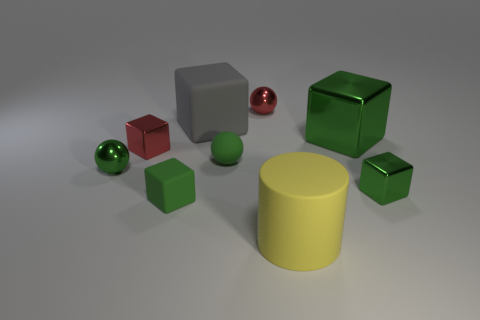Is there anything else that is the same shape as the large yellow rubber thing?
Your answer should be compact. No. What color is the big cube that is made of the same material as the yellow object?
Provide a succinct answer. Gray. There is a shiny sphere that is behind the small shiny cube that is to the left of the yellow cylinder; are there any rubber balls behind it?
Give a very brief answer. No. Is the number of big gray blocks that are on the right side of the tiny rubber cube less than the number of yellow things behind the large gray matte object?
Make the answer very short. No. How many yellow objects are the same material as the large gray block?
Your answer should be compact. 1. There is a green rubber cube; is it the same size as the green metallic thing that is behind the red block?
Your answer should be compact. No. What is the material of the big thing that is the same color as the matte ball?
Provide a short and direct response. Metal. There is a gray block to the left of the tiny cube that is on the right side of the large matte thing behind the large rubber cylinder; what size is it?
Give a very brief answer. Large. Are there more big yellow rubber objects that are behind the big gray rubber block than tiny green metallic blocks in front of the small matte cube?
Offer a very short reply. No. There is a green shiny object that is on the left side of the large rubber cylinder; how many big gray matte things are to the left of it?
Provide a succinct answer. 0. 